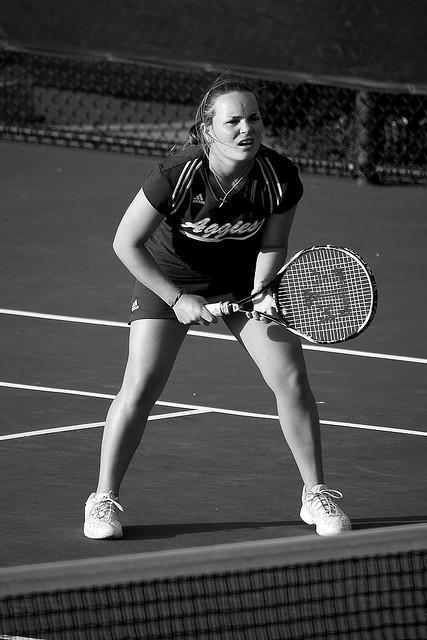How many tennis rackets are there?
Give a very brief answer. 1. 